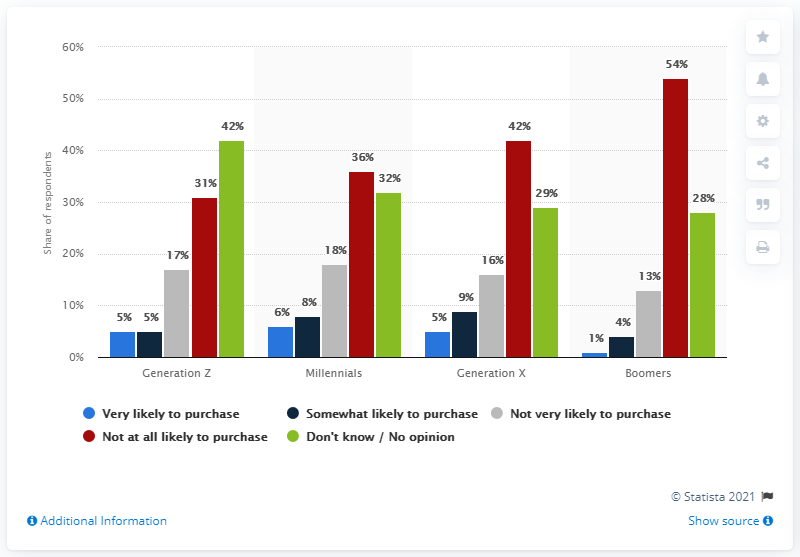Specify some key components in this picture. It is predicted that the generation least likely to purchase a subscription to Peacock is the Baby Boomers. The generation of Baby Boomers has the highest response rate of "not at all likely to purchase. According to the data, the average of "very likely to purchase" among Generation Z and millennials is 5.5%. 